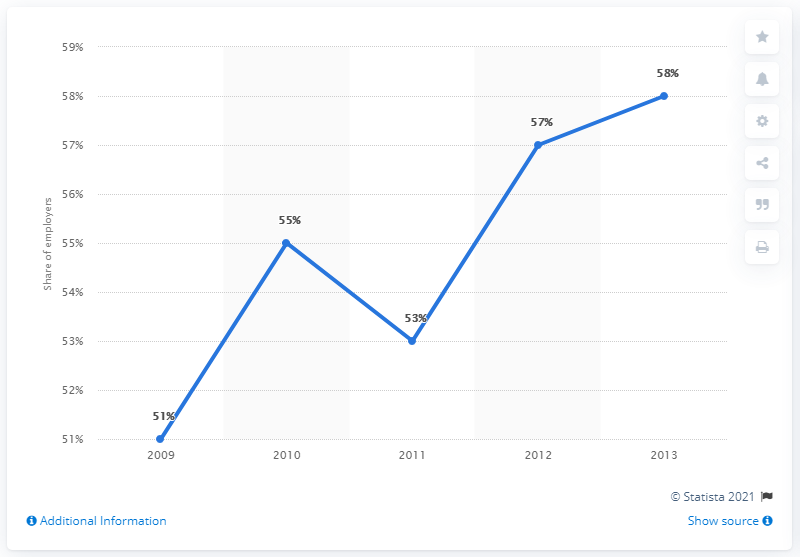List a handful of essential elements in this visual. In 2010, a higher proportion of employers offered telecommuting to their employees compared to 2012. In 2013, approximately 58% of employers offered telecommuting to their employees. In 2013, 58% of employers offered telecommuting to their employees. 